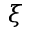<formula> <loc_0><loc_0><loc_500><loc_500>\xi</formula> 